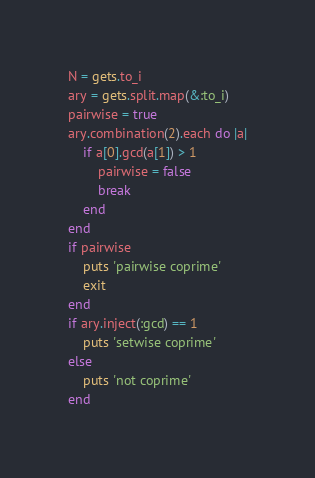<code> <loc_0><loc_0><loc_500><loc_500><_Ruby_>N = gets.to_i
ary = gets.split.map(&:to_i)
pairwise = true
ary.combination(2).each do |a|
    if a[0].gcd(a[1]) > 1
        pairwise = false
        break
    end
end
if pairwise
    puts 'pairwise coprime'
    exit
end
if ary.inject(:gcd) == 1
    puts 'setwise coprime'
else
    puts 'not coprime'
end</code> 